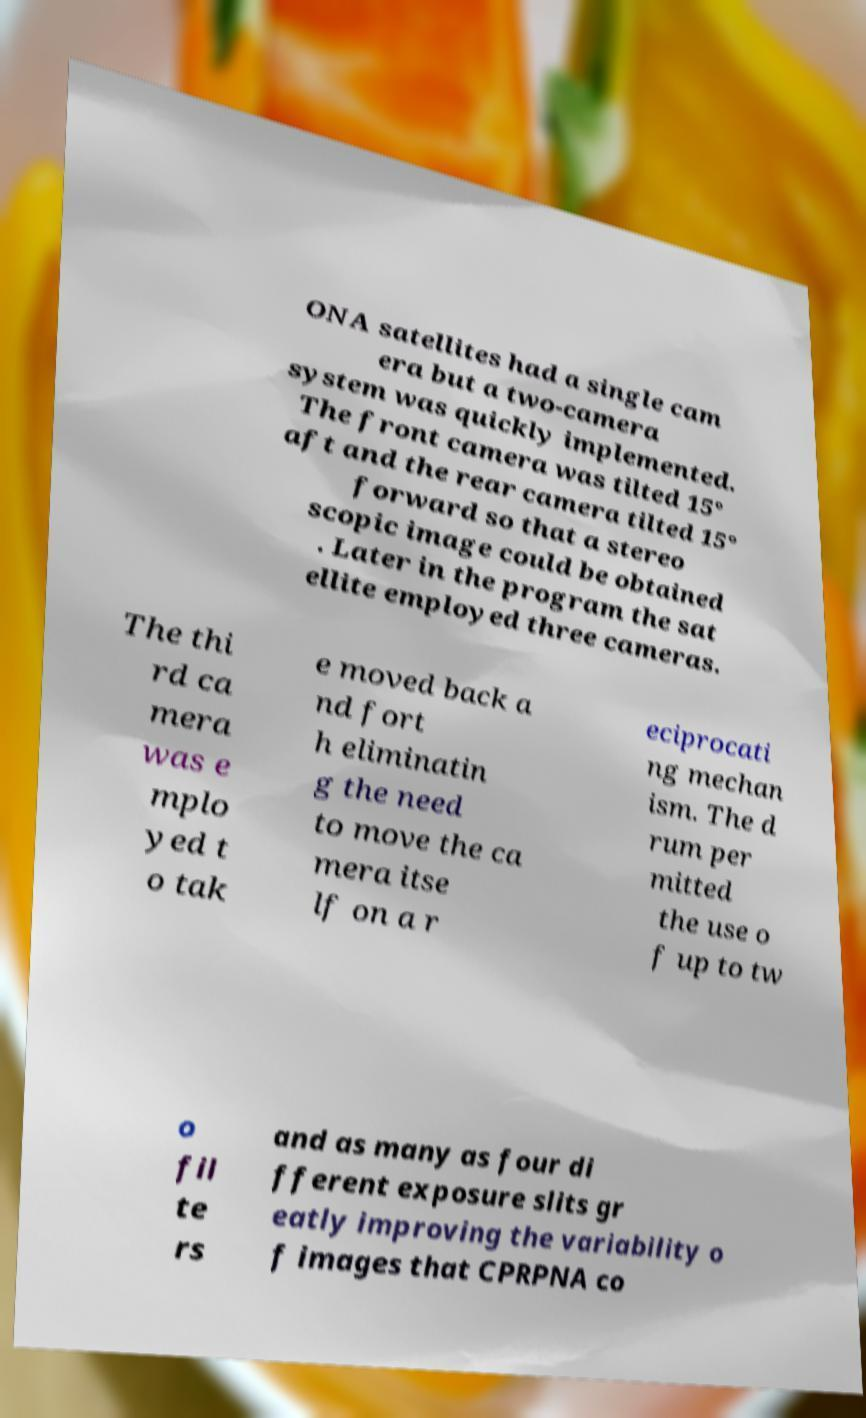Could you assist in decoding the text presented in this image and type it out clearly? ONA satellites had a single cam era but a two-camera system was quickly implemented. The front camera was tilted 15° aft and the rear camera tilted 15° forward so that a stereo scopic image could be obtained . Later in the program the sat ellite employed three cameras. The thi rd ca mera was e mplo yed t o tak e moved back a nd fort h eliminatin g the need to move the ca mera itse lf on a r eciprocati ng mechan ism. The d rum per mitted the use o f up to tw o fil te rs and as many as four di fferent exposure slits gr eatly improving the variability o f images that CPRPNA co 